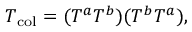Convert formula to latex. <formula><loc_0><loc_0><loc_500><loc_500>T _ { c o l } = ( T ^ { a } T ^ { b } ) ( T ^ { b } T ^ { a } ) ,</formula> 